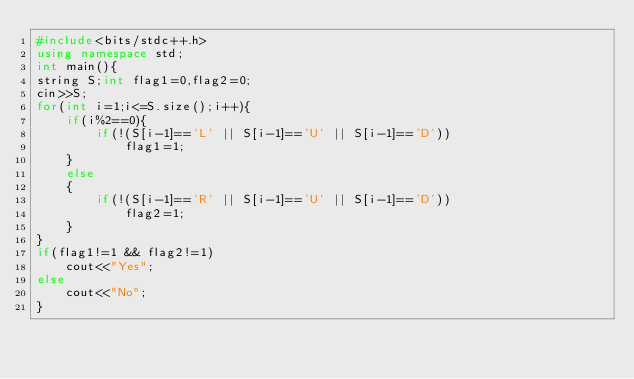<code> <loc_0><loc_0><loc_500><loc_500><_C++_>#include<bits/stdc++.h>
using namespace std;
int main(){
string S;int flag1=0,flag2=0;
cin>>S;
for(int i=1;i<=S.size();i++){
    if(i%2==0){
        if(!(S[i-1]=='L' || S[i-1]=='U' || S[i-1]=='D'))
            flag1=1;
    }
    else
    {
        if(!(S[i-1]=='R' || S[i-1]=='U' || S[i-1]=='D'))
            flag2=1;
    }
}
if(flag1!=1 && flag2!=1)
    cout<<"Yes";
else
    cout<<"No";
}


</code> 